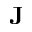Convert formula to latex. <formula><loc_0><loc_0><loc_500><loc_500>J</formula> 